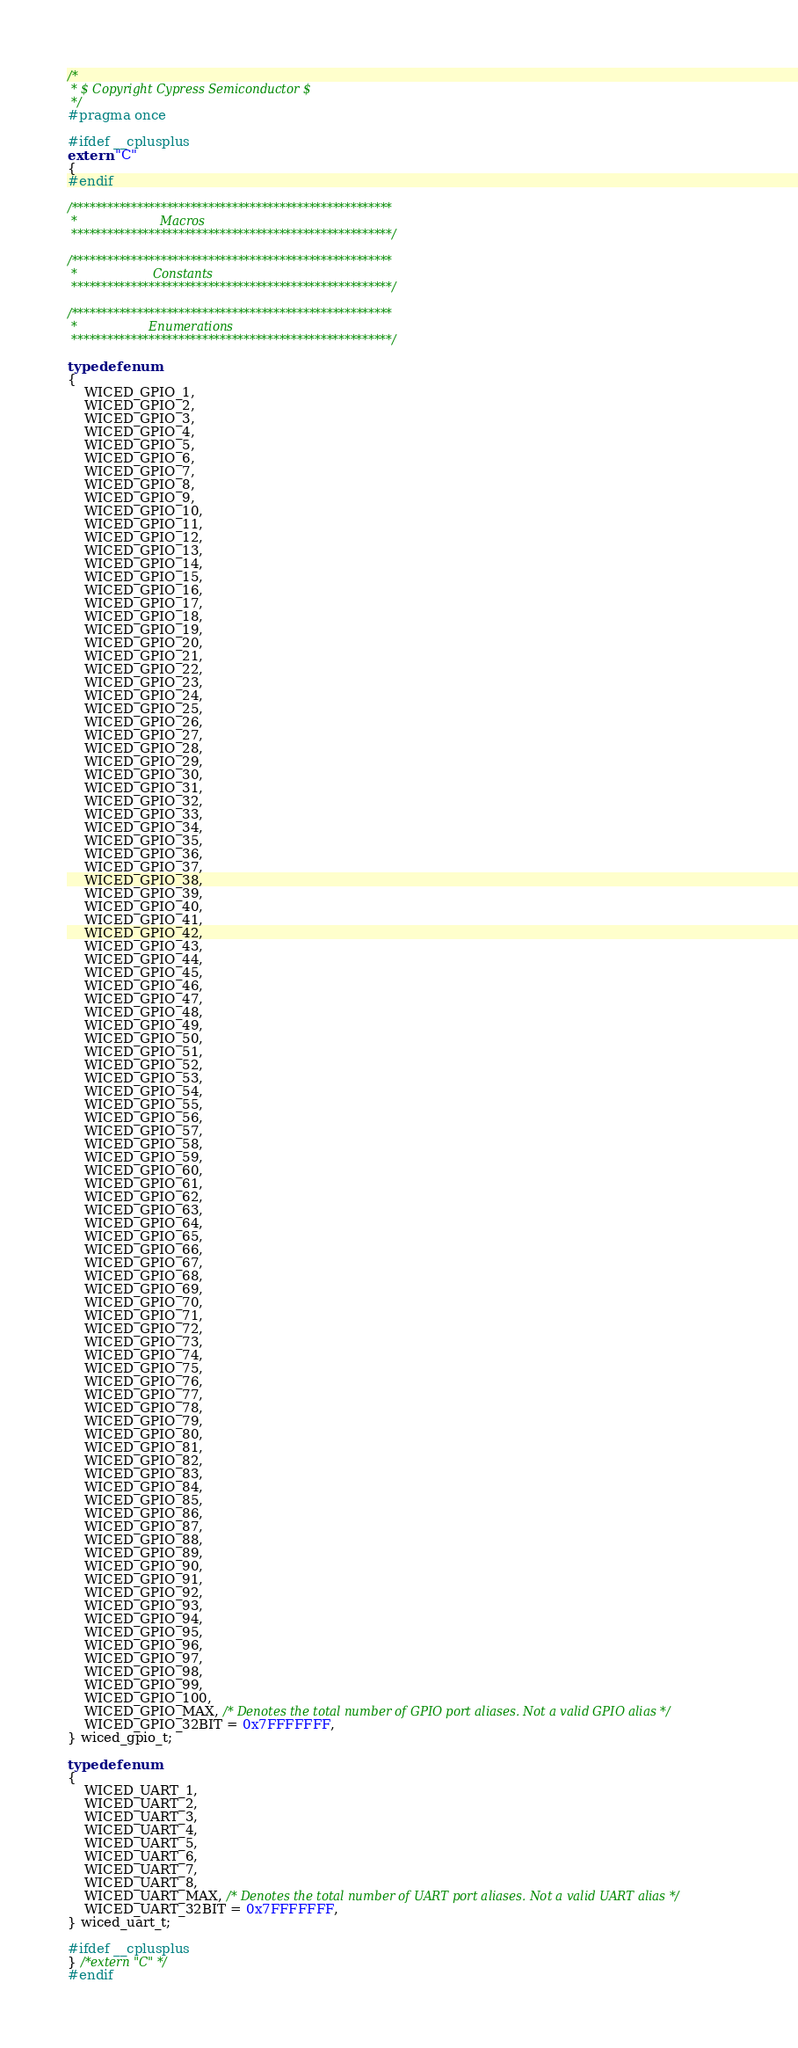Convert code to text. <code><loc_0><loc_0><loc_500><loc_500><_C_>/*
 * $ Copyright Cypress Semiconductor $
 */
#pragma once

#ifdef __cplusplus
extern "C"
{
#endif

/******************************************************
 *                      Macros
 ******************************************************/

/******************************************************
 *                    Constants
 ******************************************************/

/******************************************************
 *                   Enumerations
 ******************************************************/

typedef enum
{
    WICED_GPIO_1,
    WICED_GPIO_2,
    WICED_GPIO_3,
    WICED_GPIO_4,
    WICED_GPIO_5,
    WICED_GPIO_6,
    WICED_GPIO_7,
    WICED_GPIO_8,
    WICED_GPIO_9,
    WICED_GPIO_10,
    WICED_GPIO_11,
    WICED_GPIO_12,
    WICED_GPIO_13,
    WICED_GPIO_14,
    WICED_GPIO_15,
    WICED_GPIO_16,
    WICED_GPIO_17,
    WICED_GPIO_18,
    WICED_GPIO_19,
    WICED_GPIO_20,
    WICED_GPIO_21,
    WICED_GPIO_22,
    WICED_GPIO_23,
    WICED_GPIO_24,
    WICED_GPIO_25,
    WICED_GPIO_26,
    WICED_GPIO_27,
    WICED_GPIO_28,
    WICED_GPIO_29,
    WICED_GPIO_30,
    WICED_GPIO_31,
    WICED_GPIO_32,
    WICED_GPIO_33,
    WICED_GPIO_34,
    WICED_GPIO_35,
    WICED_GPIO_36,
    WICED_GPIO_37,
    WICED_GPIO_38,
    WICED_GPIO_39,
    WICED_GPIO_40,
    WICED_GPIO_41,
    WICED_GPIO_42,
    WICED_GPIO_43,
    WICED_GPIO_44,
    WICED_GPIO_45,
    WICED_GPIO_46,
    WICED_GPIO_47,
    WICED_GPIO_48,
    WICED_GPIO_49,
    WICED_GPIO_50,
    WICED_GPIO_51,
    WICED_GPIO_52,
    WICED_GPIO_53,
    WICED_GPIO_54,
    WICED_GPIO_55,
    WICED_GPIO_56,
    WICED_GPIO_57,
    WICED_GPIO_58,
    WICED_GPIO_59,
    WICED_GPIO_60,
    WICED_GPIO_61,
    WICED_GPIO_62,
    WICED_GPIO_63,
    WICED_GPIO_64,
    WICED_GPIO_65,
    WICED_GPIO_66,
    WICED_GPIO_67,
    WICED_GPIO_68,
    WICED_GPIO_69,
    WICED_GPIO_70,
    WICED_GPIO_71,
    WICED_GPIO_72,
    WICED_GPIO_73,
    WICED_GPIO_74,
    WICED_GPIO_75,
    WICED_GPIO_76,
    WICED_GPIO_77,
    WICED_GPIO_78,
    WICED_GPIO_79,
    WICED_GPIO_80,
    WICED_GPIO_81,
    WICED_GPIO_82,
    WICED_GPIO_83,
    WICED_GPIO_84,
    WICED_GPIO_85,
    WICED_GPIO_86,
    WICED_GPIO_87,
    WICED_GPIO_88,
    WICED_GPIO_89,
    WICED_GPIO_90,
    WICED_GPIO_91,
    WICED_GPIO_92,
    WICED_GPIO_93,
    WICED_GPIO_94,
    WICED_GPIO_95,
    WICED_GPIO_96,
    WICED_GPIO_97,
    WICED_GPIO_98,
    WICED_GPIO_99,
    WICED_GPIO_100,
    WICED_GPIO_MAX, /* Denotes the total number of GPIO port aliases. Not a valid GPIO alias */
    WICED_GPIO_32BIT = 0x7FFFFFFF,
} wiced_gpio_t;

typedef enum
{
    WICED_UART_1,
    WICED_UART_2,
    WICED_UART_3,
    WICED_UART_4,
    WICED_UART_5,
    WICED_UART_6,
    WICED_UART_7,
    WICED_UART_8,
    WICED_UART_MAX, /* Denotes the total number of UART port aliases. Not a valid UART alias */
    WICED_UART_32BIT = 0x7FFFFFFF,
} wiced_uart_t;

#ifdef __cplusplus
} /*extern "C" */
#endif
</code> 